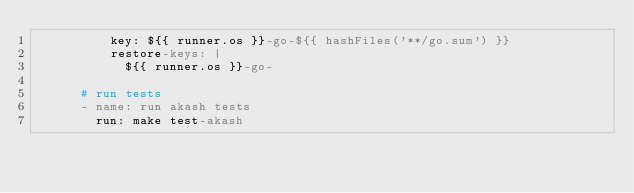Convert code to text. <code><loc_0><loc_0><loc_500><loc_500><_YAML_>          key: ${{ runner.os }}-go-${{ hashFiles('**/go.sum') }}
          restore-keys: |
            ${{ runner.os }}-go-

      # run tests
      - name: run akash tests
        run: make test-akash
</code> 